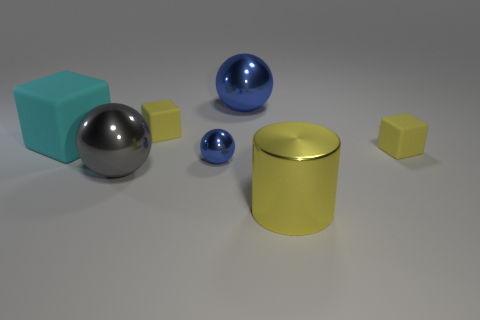Subtract all big matte blocks. How many blocks are left? 2 Add 1 brown things. How many objects exist? 8 Subtract all green blocks. How many blue spheres are left? 2 Subtract all cylinders. How many objects are left? 6 Subtract 3 cubes. How many cubes are left? 0 Subtract all cyan cubes. How many cubes are left? 2 Subtract all brown spheres. Subtract all blue blocks. How many spheres are left? 3 Subtract all tiny yellow spheres. Subtract all large rubber cubes. How many objects are left? 6 Add 6 tiny rubber blocks. How many tiny rubber blocks are left? 8 Add 6 blue shiny cylinders. How many blue shiny cylinders exist? 6 